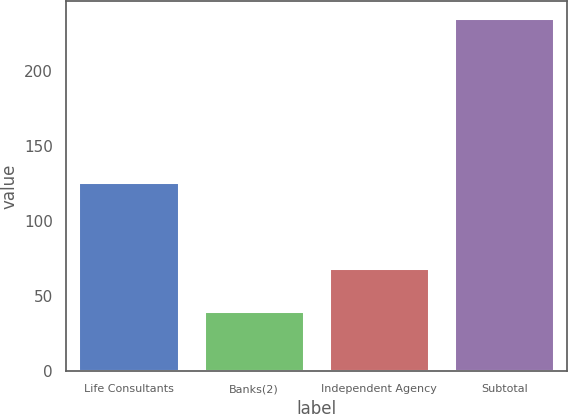Convert chart. <chart><loc_0><loc_0><loc_500><loc_500><bar_chart><fcel>Life Consultants<fcel>Banks(2)<fcel>Independent Agency<fcel>Subtotal<nl><fcel>126<fcel>40<fcel>69<fcel>235<nl></chart> 